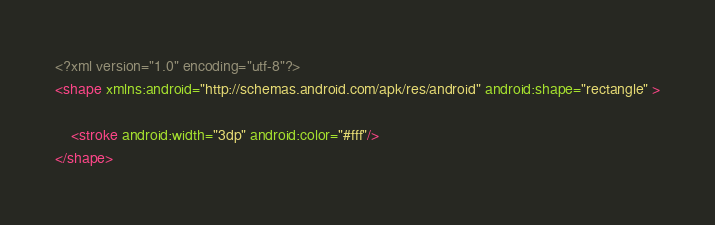<code> <loc_0><loc_0><loc_500><loc_500><_XML_><?xml version="1.0" encoding="utf-8"?>
<shape xmlns:android="http://schemas.android.com/apk/res/android" android:shape="rectangle" >

    <stroke android:width="3dp" android:color="#fff"/>
</shape></code> 